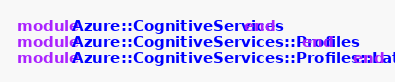Convert code to text. <code><loc_0><loc_0><loc_500><loc_500><_Ruby_>module Azure::CognitiveServices end
module Azure::CognitiveServices::Profiles end
module Azure::CognitiveServices::Profiles::Latest end
</code> 